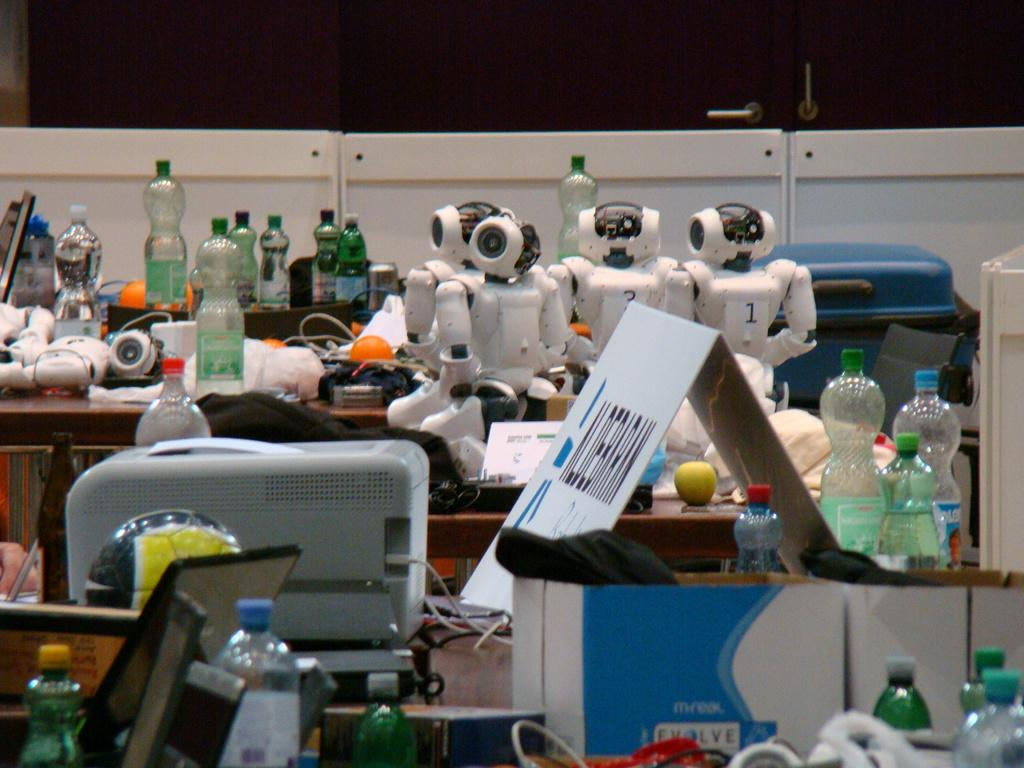What is the main subject of the image? There is a robot in the image. What other objects can be seen in the image? There are bottles, a cardboard box, a board, a ball, and wires on a table in the image. What type of cheese is being used to spell out letters on the border of the image? There is no cheese or letters present on the border of the image. 